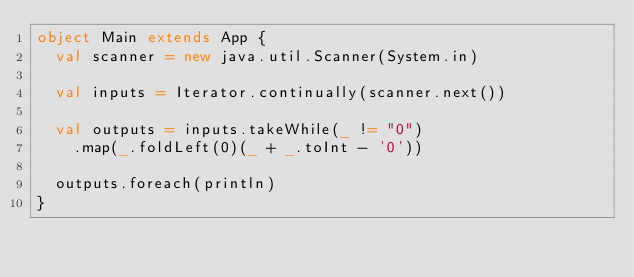Convert code to text. <code><loc_0><loc_0><loc_500><loc_500><_Scala_>object Main extends App {
  val scanner = new java.util.Scanner(System.in)

  val inputs = Iterator.continually(scanner.next())

  val outputs = inputs.takeWhile(_ != "0")
    .map(_.foldLeft(0)(_ + _.toInt - '0'))

  outputs.foreach(println)
}</code> 